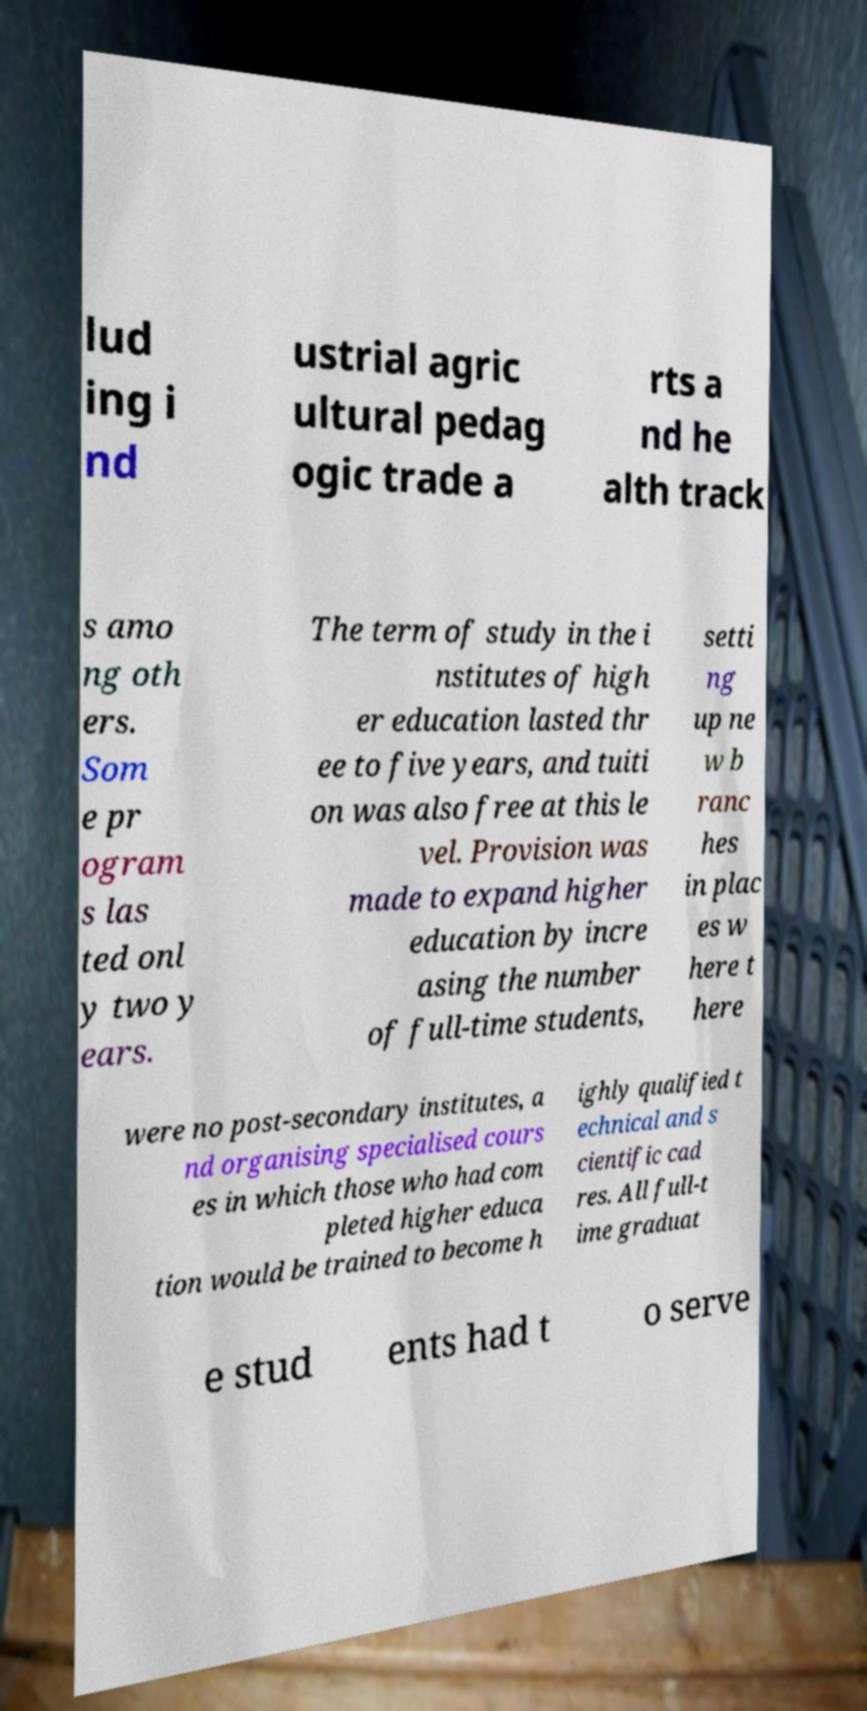Can you accurately transcribe the text from the provided image for me? lud ing i nd ustrial agric ultural pedag ogic trade a rts a nd he alth track s amo ng oth ers. Som e pr ogram s las ted onl y two y ears. The term of study in the i nstitutes of high er education lasted thr ee to five years, and tuiti on was also free at this le vel. Provision was made to expand higher education by incre asing the number of full-time students, setti ng up ne w b ranc hes in plac es w here t here were no post-secondary institutes, a nd organising specialised cours es in which those who had com pleted higher educa tion would be trained to become h ighly qualified t echnical and s cientific cad res. All full-t ime graduat e stud ents had t o serve 